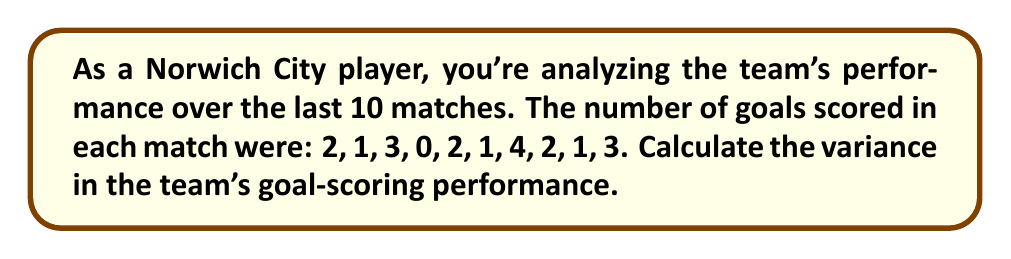Help me with this question. To calculate the variance, we'll follow these steps:

1. Calculate the mean (average) of the goals scored:
   $\mu = \frac{2 + 1 + 3 + 0 + 2 + 1 + 4 + 2 + 1 + 3}{10} = 1.9$ goals per match

2. Subtract the mean from each value and square the result:
   $(2 - 1.9)^2 = 0.01$
   $(1 - 1.9)^2 = 0.81$
   $(3 - 1.9)^2 = 1.21$
   $(0 - 1.9)^2 = 3.61$
   $(2 - 1.9)^2 = 0.01$
   $(1 - 1.9)^2 = 0.81$
   $(4 - 1.9)^2 = 4.41$
   $(2 - 1.9)^2 = 0.01$
   $(1 - 1.9)^2 = 0.81$
   $(3 - 1.9)^2 = 1.21$

3. Sum up all these squared differences:
   $0.01 + 0.81 + 1.21 + 3.61 + 0.01 + 0.81 + 4.41 + 0.01 + 0.81 + 1.21 = 12.9$

4. Divide by the number of matches (n = 10) to get the variance:
   $$\text{Variance} = \frac{\sum_{i=1}^{n} (x_i - \mu)^2}{n} = \frac{12.9}{10} = 1.29$$

Therefore, the variance in Norwich City's goal-scoring performance over the last 10 matches is 1.29.
Answer: 1.29 